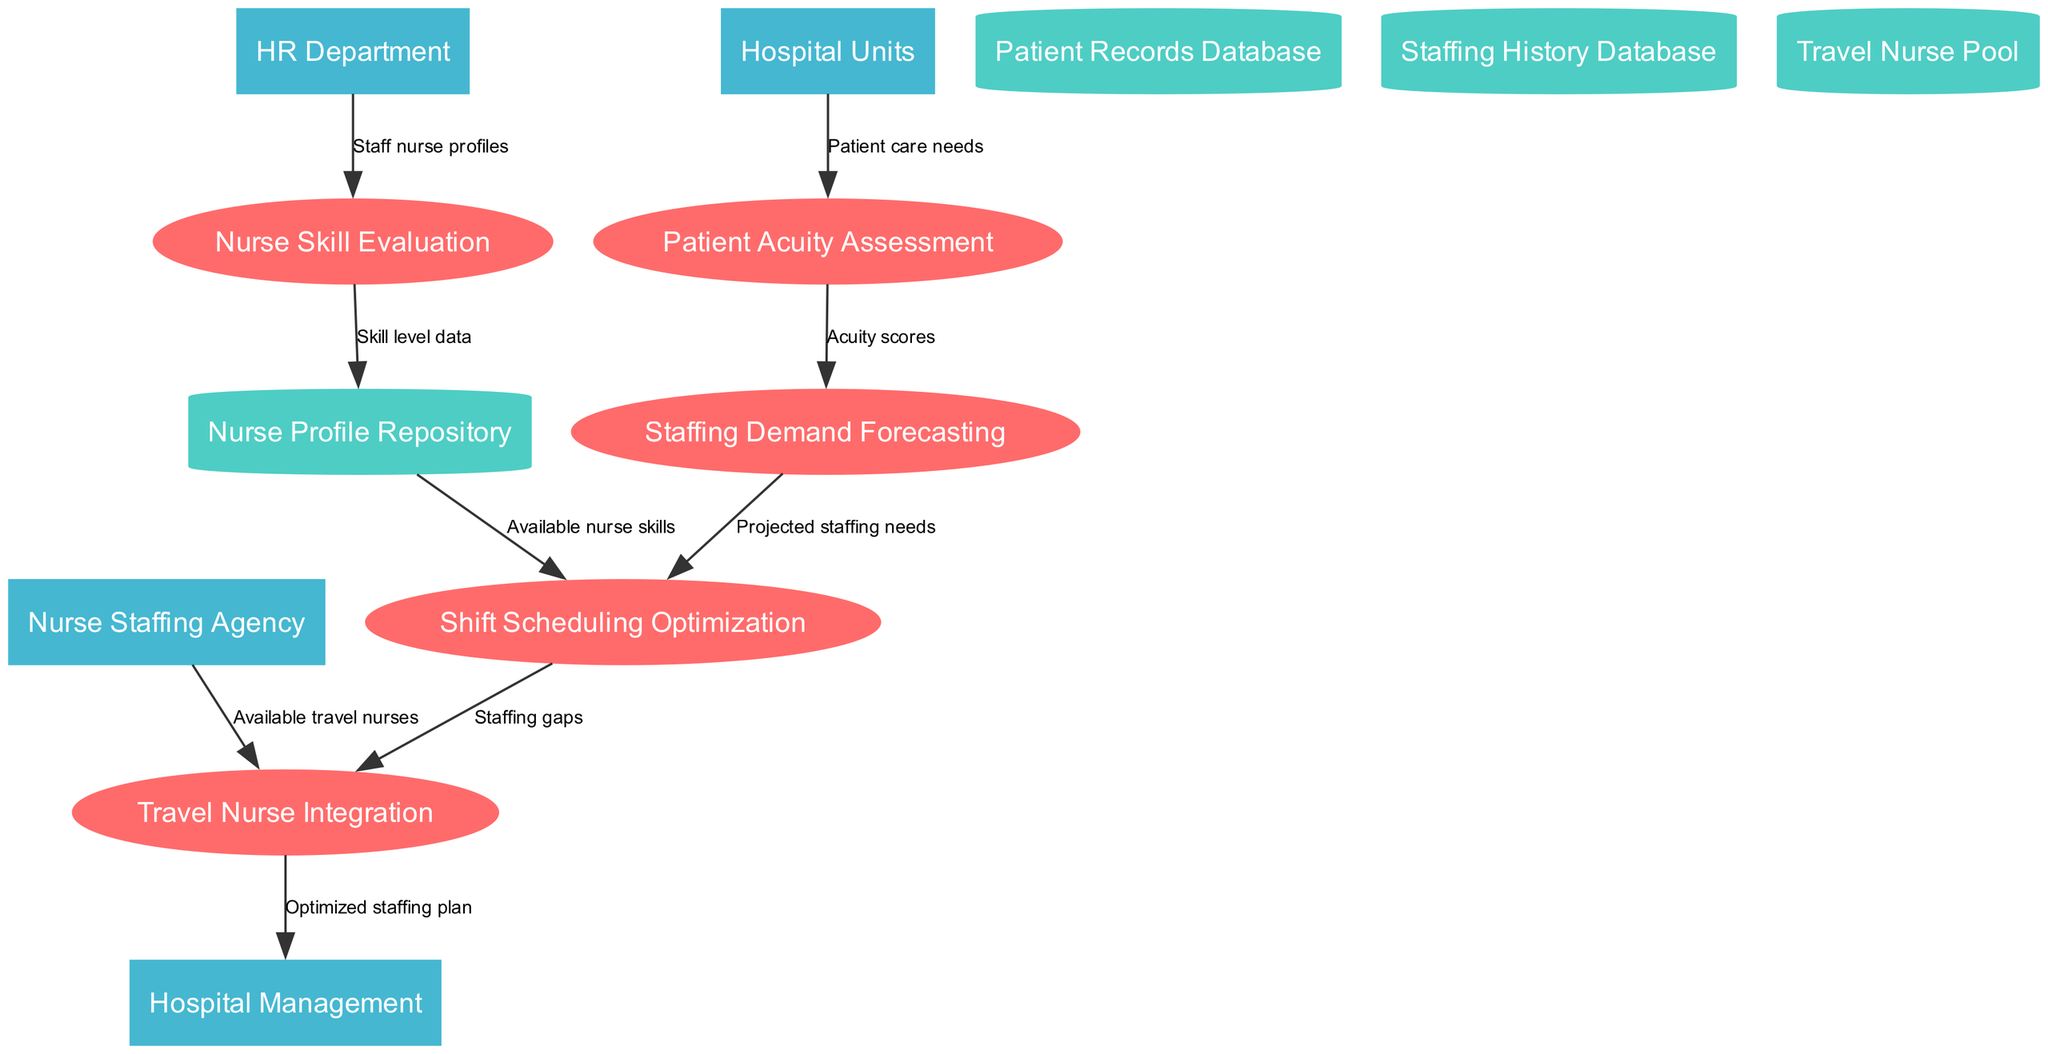What are the external entities in the diagram? The external entities are represented as rectangles in the diagram. Upon examining the nodes, we identify them as: Hospital Units, HR Department, Nurse Staffing Agency, and Hospital Management.
Answer: Hospital Units, HR Department, Nurse Staffing Agency, Hospital Management How many processes are there? By counting each of the labeled ellipse nodes in the diagram, we determine there are five distinct processes: Patient Acuity Assessment, Nurse Skill Evaluation, Staffing Demand Forecasting, Shift Scheduling Optimization, and Travel Nurse Integration.
Answer: Five What flows into the Shift Scheduling Optimization process? To find this, we look at the edges leading into the Shift Scheduling Optimization node. There are two main flows: one from the Nurse Profile Repository labeled 'Available nurse skills' and one from Staffing Demand Forecasting labeled 'Projected staffing needs.'
Answer: Available nurse skills, Projected staffing needs Which external entity provides staffing profiles to the Nurse Skill Evaluation process? Observing the flow directed from the HR Department towards Nurse Skill Evaluation, it is labeled as 'Staff nurse profiles.' This indicates that the HR Department is responsible for providing staffing profiles.
Answer: HR Department What type of data store receives skill level data? The data store that receives skill level data is the Nurse Profile Repository. This is indicated by the edge from the Nurse Skill Evaluation process to the Nurse Profile Repository.
Answer: Nurse Profile Repository Which process links staffing gaps to travel nurse integration? The edge from the Shift Scheduling Optimization process to the Travel Nurse Integration process highlights the flow labeled 'Staffing gaps.' This indicates that staffing gaps identified in scheduling are linked directly to travel nurse integration.
Answer: Staffing gaps How many data stores are there in the diagram? By inspecting the diagram, we count the data stores represented as cylinders: Patient Records Database, Nurse Profile Repository, Staffing History Database, and Travel Nurse Pool, totaling four distinct data stores.
Answer: Four Which process is the final destination for the optimized staffing plan? The flow directed from the Travel Nurse Integration process leads to the Hospital Management node, indicating that the optimized staffing plan is directed to Hospital Management.
Answer: Hospital Management 